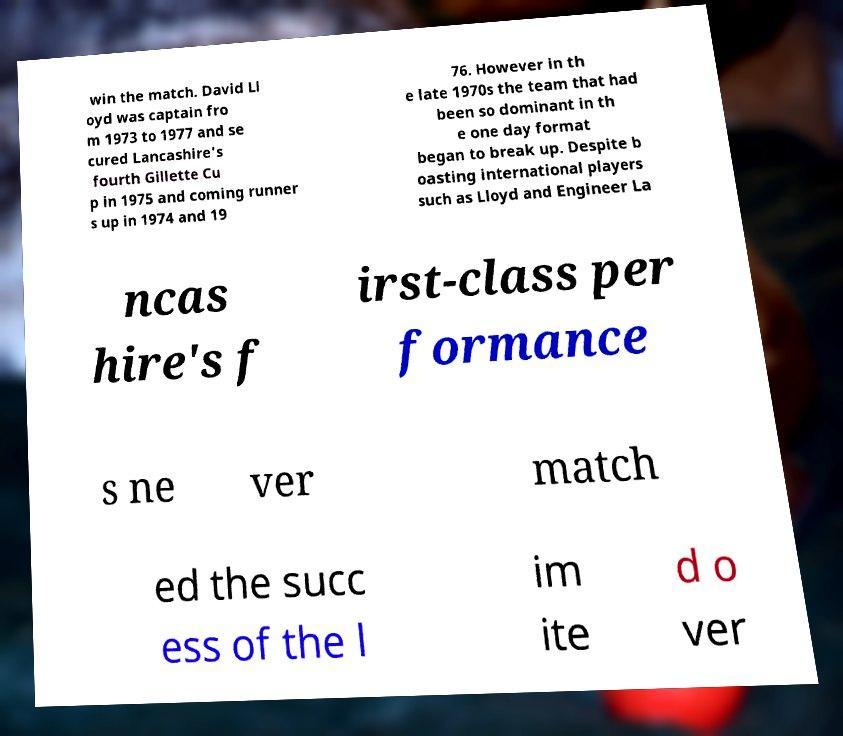I need the written content from this picture converted into text. Can you do that? win the match. David Ll oyd was captain fro m 1973 to 1977 and se cured Lancashire's fourth Gillette Cu p in 1975 and coming runner s up in 1974 and 19 76. However in th e late 1970s the team that had been so dominant in th e one day format began to break up. Despite b oasting international players such as Lloyd and Engineer La ncas hire's f irst-class per formance s ne ver match ed the succ ess of the l im ite d o ver 